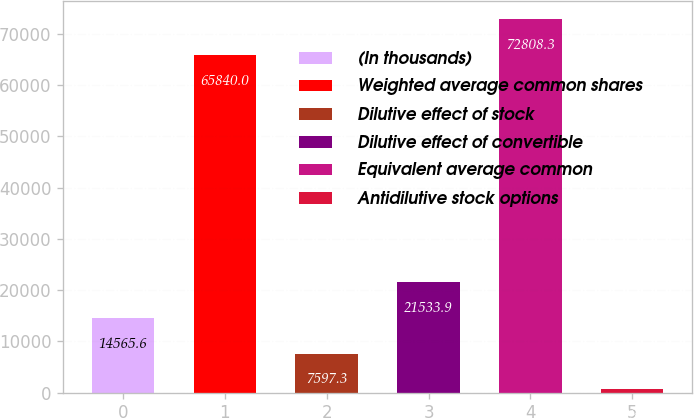Convert chart to OTSL. <chart><loc_0><loc_0><loc_500><loc_500><bar_chart><fcel>(In thousands)<fcel>Weighted average common shares<fcel>Dilutive effect of stock<fcel>Dilutive effect of convertible<fcel>Equivalent average common<fcel>Antidilutive stock options<nl><fcel>14565.6<fcel>65840<fcel>7597.3<fcel>21533.9<fcel>72808.3<fcel>629<nl></chart> 